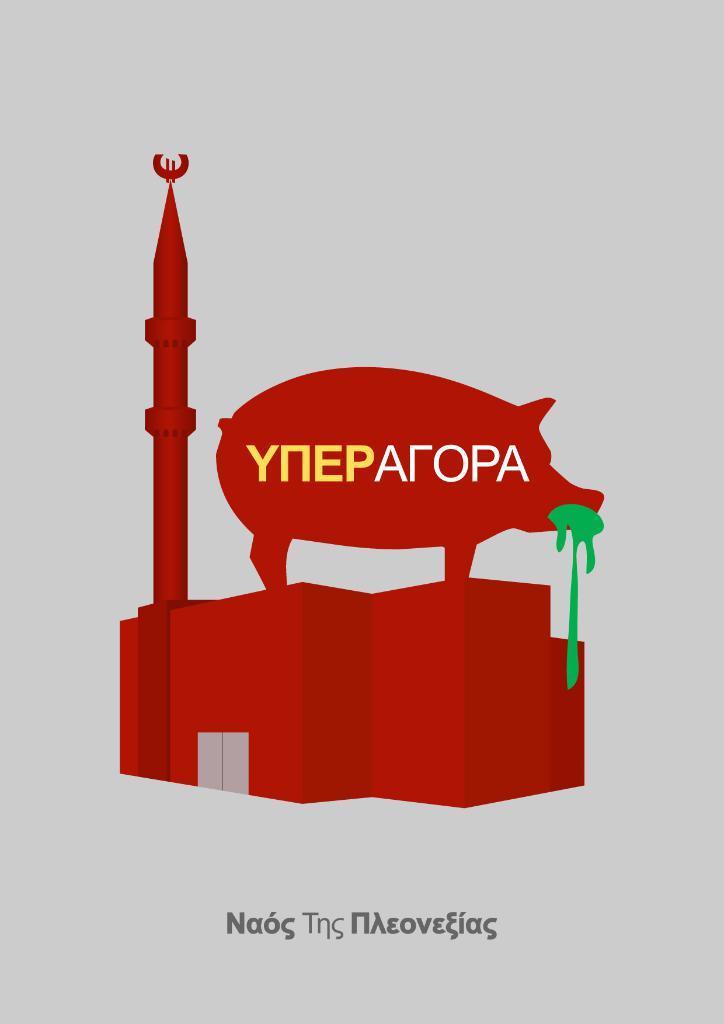In one or two sentences, can you explain what this image depicts? In this image I can see the building in red color and I can also see the animal structure on the top of the building and I can see something written on the image and I can see the white color background. 